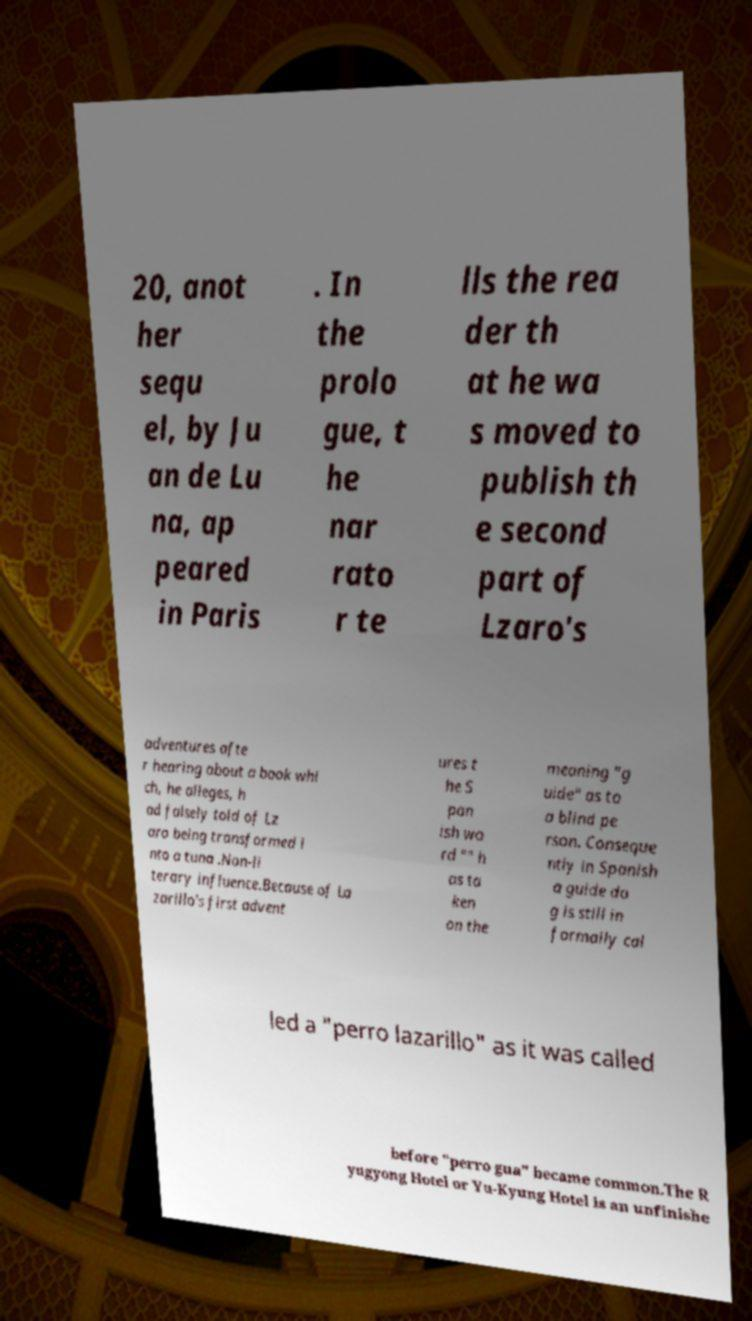What messages or text are displayed in this image? I need them in a readable, typed format. 20, anot her sequ el, by Ju an de Lu na, ap peared in Paris . In the prolo gue, t he nar rato r te lls the rea der th at he wa s moved to publish th e second part of Lzaro's adventures afte r hearing about a book whi ch, he alleges, h ad falsely told of Lz aro being transformed i nto a tuna .Non-li terary influence.Because of La zarillo's first advent ures t he S pan ish wo rd "" h as ta ken on the meaning "g uide" as to a blind pe rson. Conseque ntly in Spanish a guide do g is still in formally cal led a "perro lazarillo" as it was called before "perro gua" became common.The R yugyong Hotel or Yu-Kyung Hotel is an unfinishe 